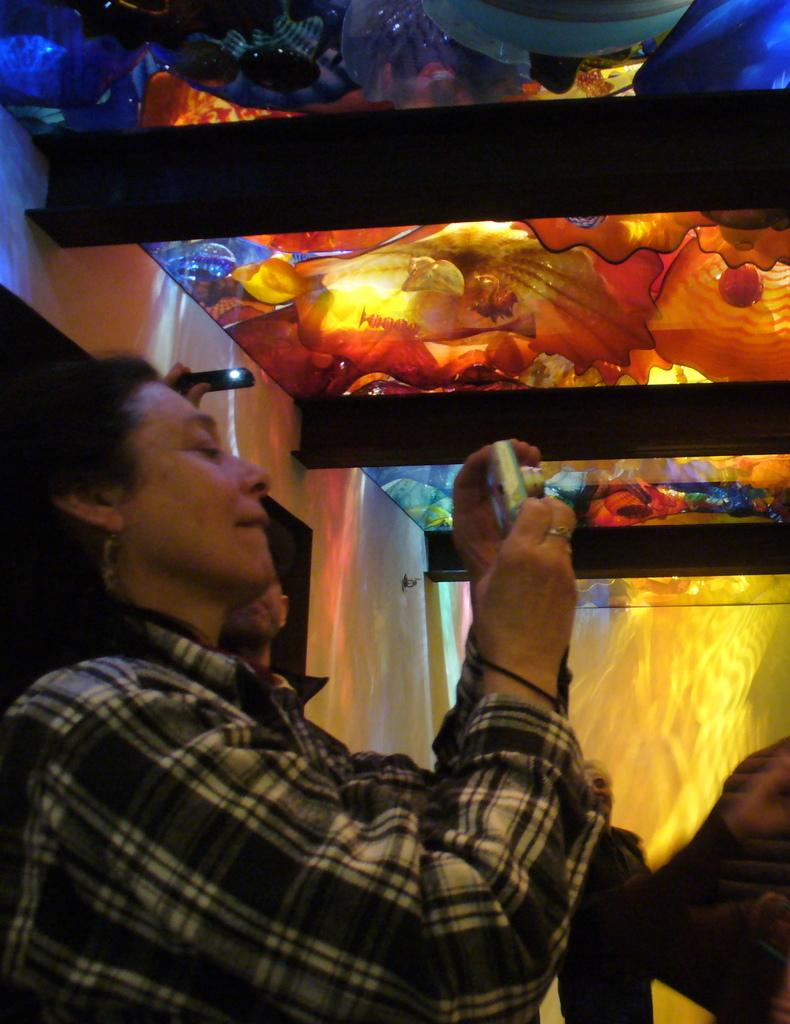Who is the main subject in the image? There is a lady in the image. Where is the lady positioned in the image? The lady is standing on the left side of the image. What is the lady holding in her hand? The lady is holding a camera in her hand. What can be seen at the top side of the image? There is a colorful roof at the top side of the image. How many cords are connected to the lady's camera in the image? There is no mention of any cords connected to the lady's camera in the image. 